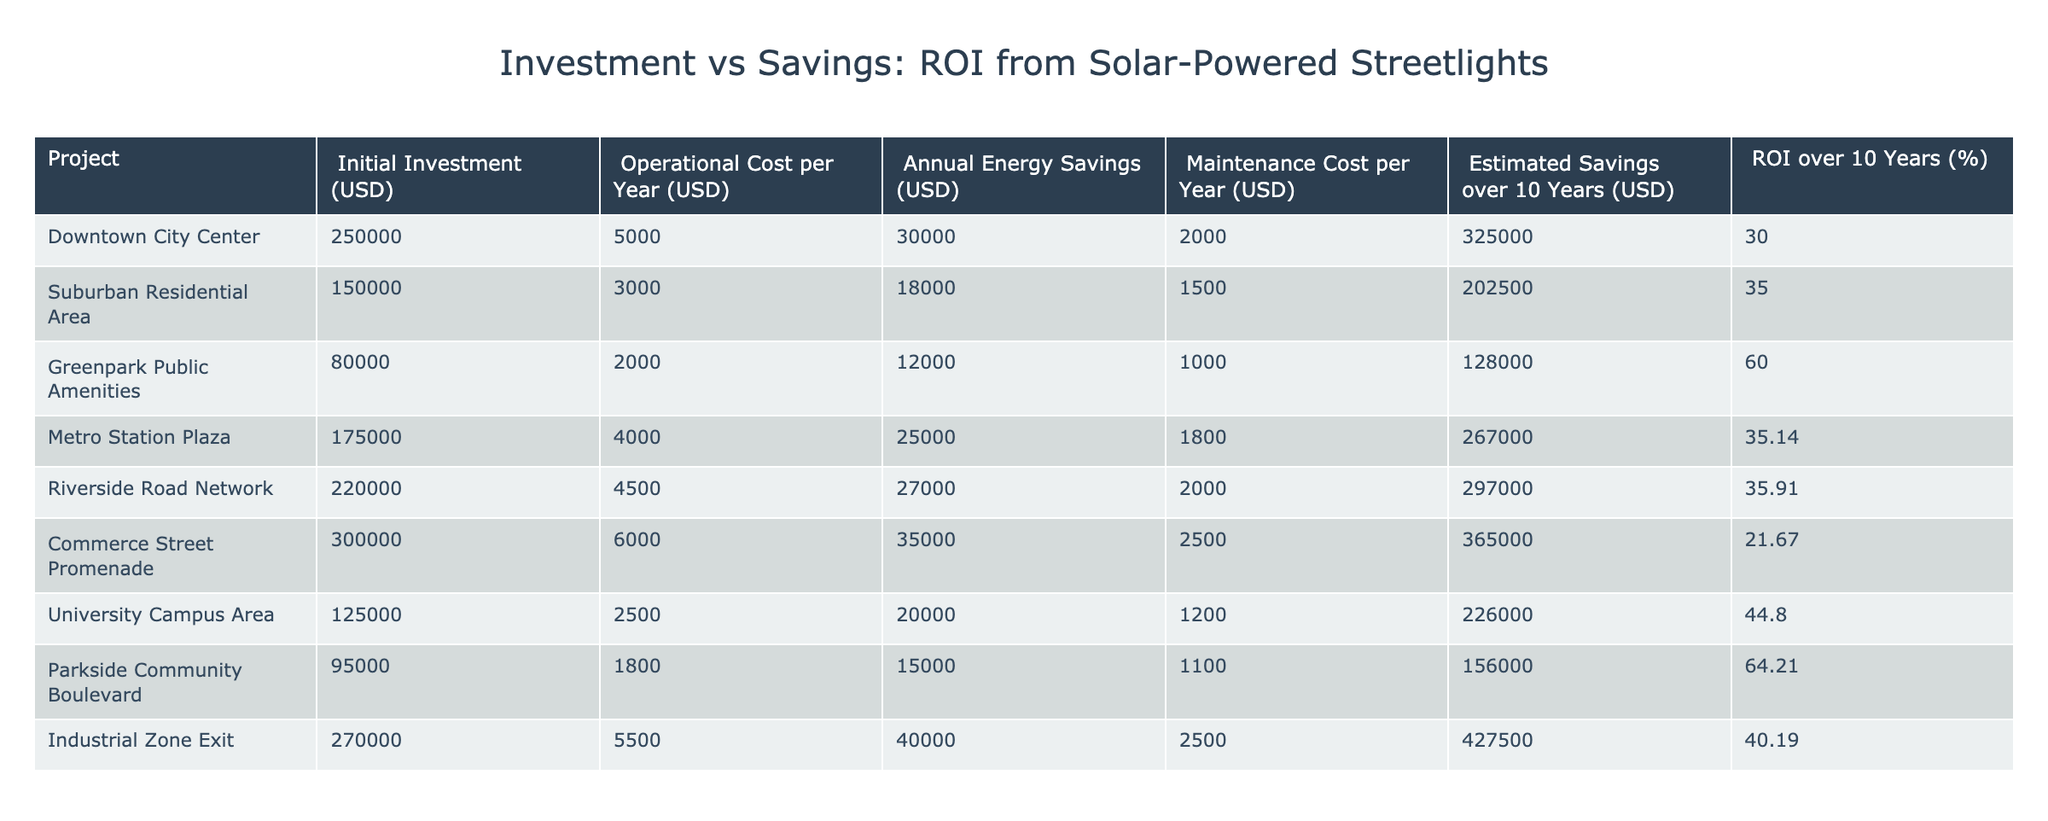What is the highest ROI over 10 years among the projects? By looking at the ROI column, I can find that the highest value is 64.21% from the Parkside Community Boulevard project.
Answer: 64.21% What is the initial investment for the Riverside Road Network project? The initial investment for Riverside Road Network is listed directly in the table as 220000 USD.
Answer: 220000 USD Which project has the lowest annual energy savings? By comparing the Annual Energy Savings column for all projects, I see that the Greenpark Public Amenities project has the lowest value at 12000 USD per year.
Answer: 12000 USD What is the average maintenance cost per year for these projects? To find the average maintenance cost, I sum the maintenance costs (2000 + 1500 + 1000 + 1800 + 2000 + 2500 + 1200 + 1100 + 2500) = 16300 USD, then divide by the number of projects (9), resulting in an average of approximately 1811.11 USD per year.
Answer: Approximately 1811.11 USD Is there any project with an ROI higher than 40%? Checking the ROI column, I find that the Parkside Community Boulevard, University Campus Area, and Industrial Zone Exit projects have ROIs greater than 40%. Therefore, there are projects that meet this criterion.
Answer: Yes Which project has the highest estimated savings over 10 years? Reviewing the Estimated Savings over 10 Years column, the Industrial Zone Exit project has the highest value of 427500 USD.
Answer: 427500 USD What is the relationship between initial investment and ROI for the projects? Analyzing the initial investment and corresponding ROI values in the table, it appears that there isn't a clear direct correlation; for instance, the Downtown City Center project has a high initial investment but a lower ROI compared to the Greenpark Public Amenities project, which has a lower initial investment but a higher ROI.
Answer: No clear relationship How much total annual operational costs are incurred across all projects? I add the operational costs for all projects: (5000 + 3000 + 2000 + 4000 + 4500 + 6000 + 2500 + 1800 + 5500) = 30300 USD for all projects combined.
Answer: 30300 USD 